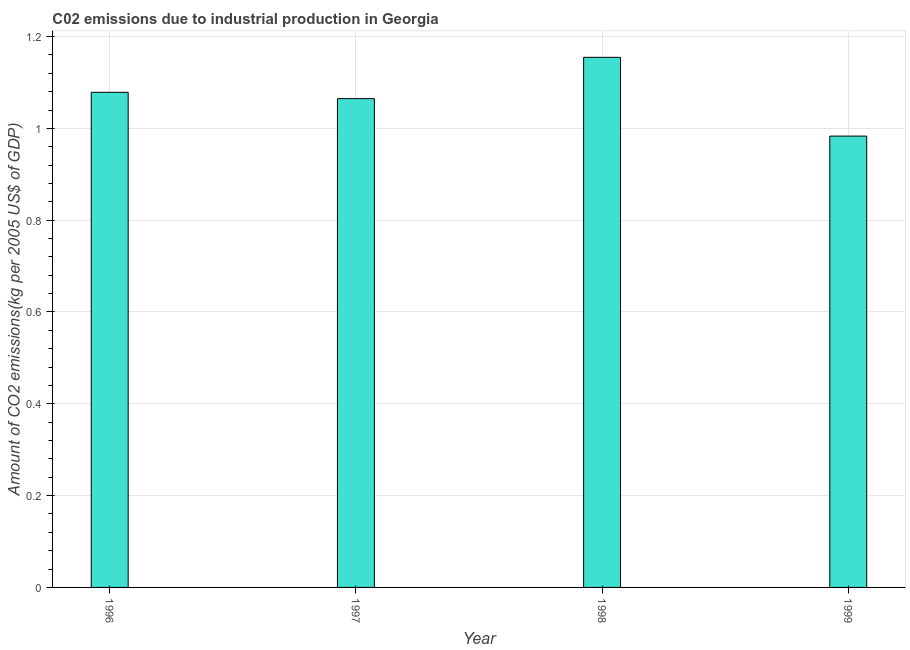Does the graph contain any zero values?
Your answer should be compact. No. What is the title of the graph?
Offer a very short reply. C02 emissions due to industrial production in Georgia. What is the label or title of the X-axis?
Keep it short and to the point. Year. What is the label or title of the Y-axis?
Your answer should be very brief. Amount of CO2 emissions(kg per 2005 US$ of GDP). What is the amount of co2 emissions in 1999?
Keep it short and to the point. 0.98. Across all years, what is the maximum amount of co2 emissions?
Offer a very short reply. 1.15. Across all years, what is the minimum amount of co2 emissions?
Provide a short and direct response. 0.98. What is the sum of the amount of co2 emissions?
Give a very brief answer. 4.28. What is the difference between the amount of co2 emissions in 1996 and 1999?
Provide a succinct answer. 0.1. What is the average amount of co2 emissions per year?
Provide a short and direct response. 1.07. What is the median amount of co2 emissions?
Give a very brief answer. 1.07. Is the difference between the amount of co2 emissions in 1997 and 1998 greater than the difference between any two years?
Provide a succinct answer. No. What is the difference between the highest and the second highest amount of co2 emissions?
Keep it short and to the point. 0.08. What is the difference between the highest and the lowest amount of co2 emissions?
Provide a short and direct response. 0.17. In how many years, is the amount of co2 emissions greater than the average amount of co2 emissions taken over all years?
Provide a short and direct response. 2. Are all the bars in the graph horizontal?
Your response must be concise. No. How many years are there in the graph?
Your response must be concise. 4. What is the difference between two consecutive major ticks on the Y-axis?
Your answer should be compact. 0.2. Are the values on the major ticks of Y-axis written in scientific E-notation?
Keep it short and to the point. No. What is the Amount of CO2 emissions(kg per 2005 US$ of GDP) in 1996?
Ensure brevity in your answer.  1.08. What is the Amount of CO2 emissions(kg per 2005 US$ of GDP) in 1997?
Offer a terse response. 1.06. What is the Amount of CO2 emissions(kg per 2005 US$ of GDP) of 1998?
Offer a very short reply. 1.15. What is the Amount of CO2 emissions(kg per 2005 US$ of GDP) in 1999?
Provide a short and direct response. 0.98. What is the difference between the Amount of CO2 emissions(kg per 2005 US$ of GDP) in 1996 and 1997?
Offer a very short reply. 0.01. What is the difference between the Amount of CO2 emissions(kg per 2005 US$ of GDP) in 1996 and 1998?
Provide a short and direct response. -0.08. What is the difference between the Amount of CO2 emissions(kg per 2005 US$ of GDP) in 1996 and 1999?
Provide a succinct answer. 0.1. What is the difference between the Amount of CO2 emissions(kg per 2005 US$ of GDP) in 1997 and 1998?
Offer a very short reply. -0.09. What is the difference between the Amount of CO2 emissions(kg per 2005 US$ of GDP) in 1997 and 1999?
Ensure brevity in your answer.  0.08. What is the difference between the Amount of CO2 emissions(kg per 2005 US$ of GDP) in 1998 and 1999?
Provide a succinct answer. 0.17. What is the ratio of the Amount of CO2 emissions(kg per 2005 US$ of GDP) in 1996 to that in 1998?
Your answer should be compact. 0.93. What is the ratio of the Amount of CO2 emissions(kg per 2005 US$ of GDP) in 1996 to that in 1999?
Provide a short and direct response. 1.1. What is the ratio of the Amount of CO2 emissions(kg per 2005 US$ of GDP) in 1997 to that in 1998?
Offer a terse response. 0.92. What is the ratio of the Amount of CO2 emissions(kg per 2005 US$ of GDP) in 1997 to that in 1999?
Your answer should be compact. 1.08. What is the ratio of the Amount of CO2 emissions(kg per 2005 US$ of GDP) in 1998 to that in 1999?
Make the answer very short. 1.18. 